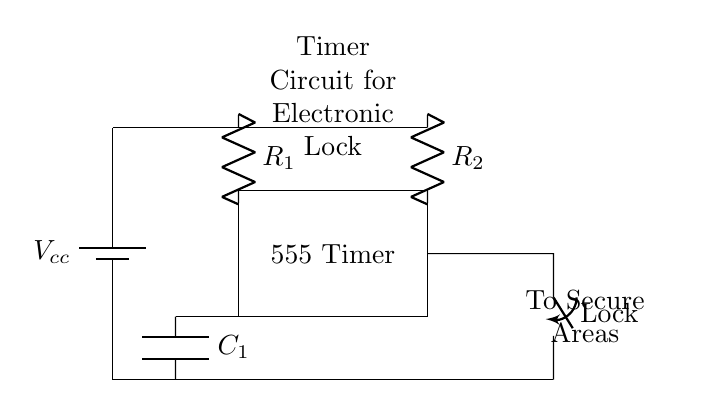What is the component used for timing in this circuit? The timing function is performed by the capacitor labeled C1, which works in conjunction with resistors R1 and R2 to set the timing interval for the lock mechanism.
Answer: C1 What is the purpose of the 555 Timer in this circuit? The 555 timer acts as a control device that generates a timed output signal to open or close the lock, based on the timing parameters set by R1, R2, and C1.
Answer: Control device Which element secures access to certain areas? The lock mechanism, indicated as the closing switch in the diagram, is responsible for securing access by being controlled by the output of the 555 Timer.
Answer: Lock What type of components are R1 and R2? Both R1 and R2 are resistors that are crucial for defining the timing behavior of the 555 Timer, impacting how quickly the output can change based on the timing configuration.
Answer: Resistors How would the timing interval change if R1 was increased? Increasing R1 would lengthen the timing interval, as the timer's output duration is directly proportional to the values of R1 and C1 in the circuit, resulting in a longer delay before the lock activates or deactivates.
Answer: Longer delay What is the supply voltage for this circuit? The circuit is powered by a battery with voltage denoted as Vcc, and since it is not specified in the diagram, it is typically referred to in standard terms in a design context.
Answer: Vcc 